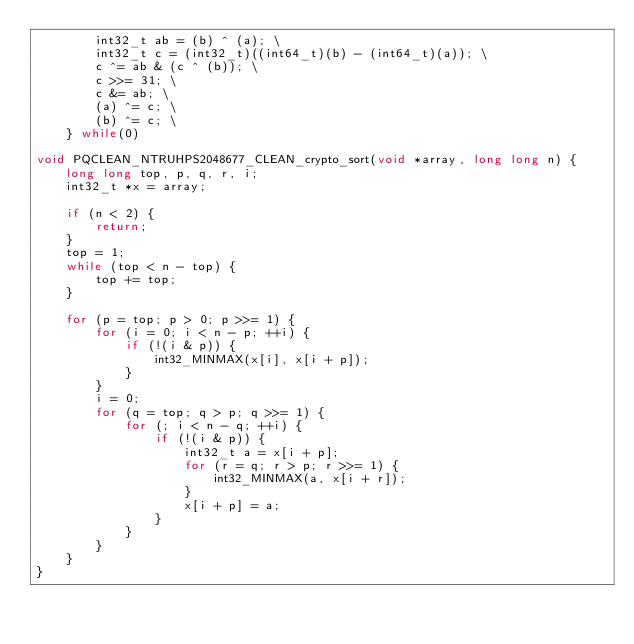Convert code to text. <code><loc_0><loc_0><loc_500><loc_500><_C_>        int32_t ab = (b) ^ (a); \
        int32_t c = (int32_t)((int64_t)(b) - (int64_t)(a)); \
        c ^= ab & (c ^ (b)); \
        c >>= 31; \
        c &= ab; \
        (a) ^= c; \
        (b) ^= c; \
    } while(0)

void PQCLEAN_NTRUHPS2048677_CLEAN_crypto_sort(void *array, long long n) {
    long long top, p, q, r, i;
    int32_t *x = array;

    if (n < 2) {
        return;
    }
    top = 1;
    while (top < n - top) {
        top += top;
    }

    for (p = top; p > 0; p >>= 1) {
        for (i = 0; i < n - p; ++i) {
            if (!(i & p)) {
                int32_MINMAX(x[i], x[i + p]);
            }
        }
        i = 0;
        for (q = top; q > p; q >>= 1) {
            for (; i < n - q; ++i) {
                if (!(i & p)) {
                    int32_t a = x[i + p];
                    for (r = q; r > p; r >>= 1) {
                        int32_MINMAX(a, x[i + r]);
                    }
                    x[i + p] = a;
                }
            }
        }
    }
}
</code> 